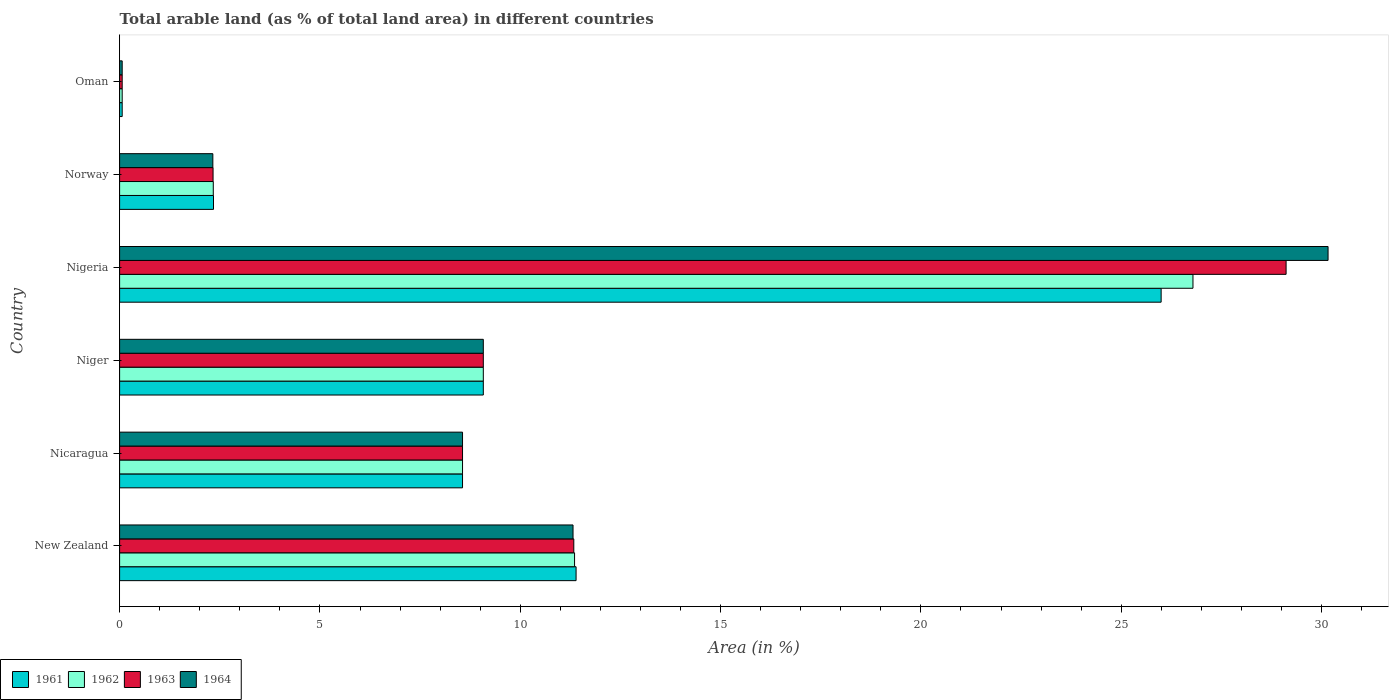How many different coloured bars are there?
Your answer should be very brief. 4. How many groups of bars are there?
Provide a short and direct response. 6. Are the number of bars on each tick of the Y-axis equal?
Your answer should be very brief. Yes. What is the label of the 1st group of bars from the top?
Make the answer very short. Oman. In how many cases, is the number of bars for a given country not equal to the number of legend labels?
Provide a succinct answer. 0. What is the percentage of arable land in 1964 in Niger?
Your answer should be very brief. 9.08. Across all countries, what is the maximum percentage of arable land in 1964?
Offer a very short reply. 30.16. Across all countries, what is the minimum percentage of arable land in 1961?
Your answer should be compact. 0.06. In which country was the percentage of arable land in 1961 maximum?
Provide a succinct answer. Nigeria. In which country was the percentage of arable land in 1961 minimum?
Provide a succinct answer. Oman. What is the total percentage of arable land in 1962 in the graph?
Your answer should be very brief. 58.19. What is the difference between the percentage of arable land in 1962 in New Zealand and that in Nicaragua?
Provide a short and direct response. 2.8. What is the difference between the percentage of arable land in 1962 in Nigeria and the percentage of arable land in 1961 in Oman?
Ensure brevity in your answer.  26.73. What is the average percentage of arable land in 1962 per country?
Your response must be concise. 9.7. What is the difference between the percentage of arable land in 1961 and percentage of arable land in 1964 in New Zealand?
Keep it short and to the point. 0.08. In how many countries, is the percentage of arable land in 1962 greater than 21 %?
Make the answer very short. 1. What is the ratio of the percentage of arable land in 1961 in Nicaragua to that in Oman?
Provide a succinct answer. 132.45. Is the percentage of arable land in 1962 in Nicaragua less than that in Nigeria?
Provide a succinct answer. Yes. What is the difference between the highest and the second highest percentage of arable land in 1963?
Your answer should be very brief. 17.78. What is the difference between the highest and the lowest percentage of arable land in 1961?
Offer a very short reply. 25.93. Is the sum of the percentage of arable land in 1961 in Nicaragua and Oman greater than the maximum percentage of arable land in 1963 across all countries?
Your answer should be very brief. No. What does the 2nd bar from the top in New Zealand represents?
Your response must be concise. 1963. What does the 4th bar from the bottom in Norway represents?
Offer a terse response. 1964. How many bars are there?
Provide a succinct answer. 24. Are all the bars in the graph horizontal?
Your answer should be compact. Yes. How are the legend labels stacked?
Offer a terse response. Horizontal. What is the title of the graph?
Ensure brevity in your answer.  Total arable land (as % of total land area) in different countries. What is the label or title of the X-axis?
Offer a terse response. Area (in %). What is the Area (in %) in 1961 in New Zealand?
Your response must be concise. 11.39. What is the Area (in %) in 1962 in New Zealand?
Keep it short and to the point. 11.36. What is the Area (in %) in 1963 in New Zealand?
Your response must be concise. 11.34. What is the Area (in %) in 1964 in New Zealand?
Offer a very short reply. 11.32. What is the Area (in %) of 1961 in Nicaragua?
Give a very brief answer. 8.56. What is the Area (in %) of 1962 in Nicaragua?
Offer a terse response. 8.56. What is the Area (in %) in 1963 in Nicaragua?
Ensure brevity in your answer.  8.56. What is the Area (in %) of 1964 in Nicaragua?
Ensure brevity in your answer.  8.56. What is the Area (in %) in 1961 in Niger?
Offer a very short reply. 9.08. What is the Area (in %) in 1962 in Niger?
Make the answer very short. 9.08. What is the Area (in %) in 1963 in Niger?
Your response must be concise. 9.08. What is the Area (in %) of 1964 in Niger?
Provide a short and direct response. 9.08. What is the Area (in %) of 1961 in Nigeria?
Ensure brevity in your answer.  26. What is the Area (in %) in 1962 in Nigeria?
Your answer should be very brief. 26.79. What is the Area (in %) of 1963 in Nigeria?
Give a very brief answer. 29.11. What is the Area (in %) in 1964 in Nigeria?
Your response must be concise. 30.16. What is the Area (in %) in 1961 in Norway?
Offer a very short reply. 2.34. What is the Area (in %) in 1962 in Norway?
Keep it short and to the point. 2.34. What is the Area (in %) in 1963 in Norway?
Your answer should be compact. 2.33. What is the Area (in %) in 1964 in Norway?
Keep it short and to the point. 2.33. What is the Area (in %) in 1961 in Oman?
Ensure brevity in your answer.  0.06. What is the Area (in %) of 1962 in Oman?
Keep it short and to the point. 0.06. What is the Area (in %) in 1963 in Oman?
Make the answer very short. 0.06. What is the Area (in %) in 1964 in Oman?
Your answer should be compact. 0.06. Across all countries, what is the maximum Area (in %) of 1961?
Ensure brevity in your answer.  26. Across all countries, what is the maximum Area (in %) of 1962?
Give a very brief answer. 26.79. Across all countries, what is the maximum Area (in %) of 1963?
Provide a short and direct response. 29.11. Across all countries, what is the maximum Area (in %) of 1964?
Provide a succinct answer. 30.16. Across all countries, what is the minimum Area (in %) in 1961?
Provide a short and direct response. 0.06. Across all countries, what is the minimum Area (in %) in 1962?
Give a very brief answer. 0.06. Across all countries, what is the minimum Area (in %) in 1963?
Keep it short and to the point. 0.06. Across all countries, what is the minimum Area (in %) in 1964?
Ensure brevity in your answer.  0.06. What is the total Area (in %) in 1961 in the graph?
Keep it short and to the point. 57.43. What is the total Area (in %) in 1962 in the graph?
Ensure brevity in your answer.  58.19. What is the total Area (in %) of 1963 in the graph?
Your response must be concise. 60.49. What is the total Area (in %) of 1964 in the graph?
Provide a succinct answer. 61.51. What is the difference between the Area (in %) of 1961 in New Zealand and that in Nicaragua?
Provide a succinct answer. 2.83. What is the difference between the Area (in %) of 1962 in New Zealand and that in Nicaragua?
Ensure brevity in your answer.  2.8. What is the difference between the Area (in %) of 1963 in New Zealand and that in Nicaragua?
Give a very brief answer. 2.78. What is the difference between the Area (in %) of 1964 in New Zealand and that in Nicaragua?
Keep it short and to the point. 2.76. What is the difference between the Area (in %) in 1961 in New Zealand and that in Niger?
Keep it short and to the point. 2.32. What is the difference between the Area (in %) of 1962 in New Zealand and that in Niger?
Make the answer very short. 2.28. What is the difference between the Area (in %) of 1963 in New Zealand and that in Niger?
Give a very brief answer. 2.26. What is the difference between the Area (in %) of 1964 in New Zealand and that in Niger?
Keep it short and to the point. 2.24. What is the difference between the Area (in %) in 1961 in New Zealand and that in Nigeria?
Your response must be concise. -14.6. What is the difference between the Area (in %) in 1962 in New Zealand and that in Nigeria?
Offer a very short reply. -15.44. What is the difference between the Area (in %) in 1963 in New Zealand and that in Nigeria?
Give a very brief answer. -17.78. What is the difference between the Area (in %) of 1964 in New Zealand and that in Nigeria?
Offer a very short reply. -18.84. What is the difference between the Area (in %) in 1961 in New Zealand and that in Norway?
Offer a very short reply. 9.05. What is the difference between the Area (in %) in 1962 in New Zealand and that in Norway?
Your answer should be compact. 9.02. What is the difference between the Area (in %) of 1963 in New Zealand and that in Norway?
Your answer should be compact. 9. What is the difference between the Area (in %) in 1964 in New Zealand and that in Norway?
Make the answer very short. 8.99. What is the difference between the Area (in %) of 1961 in New Zealand and that in Oman?
Your response must be concise. 11.33. What is the difference between the Area (in %) in 1962 in New Zealand and that in Oman?
Provide a succinct answer. 11.29. What is the difference between the Area (in %) of 1963 in New Zealand and that in Oman?
Your response must be concise. 11.27. What is the difference between the Area (in %) in 1964 in New Zealand and that in Oman?
Provide a succinct answer. 11.25. What is the difference between the Area (in %) in 1961 in Nicaragua and that in Niger?
Your answer should be compact. -0.52. What is the difference between the Area (in %) in 1962 in Nicaragua and that in Niger?
Provide a succinct answer. -0.52. What is the difference between the Area (in %) in 1963 in Nicaragua and that in Niger?
Provide a short and direct response. -0.52. What is the difference between the Area (in %) in 1964 in Nicaragua and that in Niger?
Keep it short and to the point. -0.52. What is the difference between the Area (in %) of 1961 in Nicaragua and that in Nigeria?
Offer a terse response. -17.44. What is the difference between the Area (in %) in 1962 in Nicaragua and that in Nigeria?
Provide a succinct answer. -18.23. What is the difference between the Area (in %) in 1963 in Nicaragua and that in Nigeria?
Provide a succinct answer. -20.56. What is the difference between the Area (in %) in 1964 in Nicaragua and that in Nigeria?
Provide a succinct answer. -21.6. What is the difference between the Area (in %) in 1961 in Nicaragua and that in Norway?
Provide a succinct answer. 6.22. What is the difference between the Area (in %) of 1962 in Nicaragua and that in Norway?
Your answer should be compact. 6.22. What is the difference between the Area (in %) in 1963 in Nicaragua and that in Norway?
Ensure brevity in your answer.  6.23. What is the difference between the Area (in %) in 1964 in Nicaragua and that in Norway?
Keep it short and to the point. 6.23. What is the difference between the Area (in %) in 1961 in Nicaragua and that in Oman?
Offer a terse response. 8.49. What is the difference between the Area (in %) in 1962 in Nicaragua and that in Oman?
Provide a short and direct response. 8.49. What is the difference between the Area (in %) in 1963 in Nicaragua and that in Oman?
Give a very brief answer. 8.49. What is the difference between the Area (in %) in 1964 in Nicaragua and that in Oman?
Keep it short and to the point. 8.49. What is the difference between the Area (in %) in 1961 in Niger and that in Nigeria?
Offer a terse response. -16.92. What is the difference between the Area (in %) of 1962 in Niger and that in Nigeria?
Give a very brief answer. -17.71. What is the difference between the Area (in %) in 1963 in Niger and that in Nigeria?
Ensure brevity in your answer.  -20.04. What is the difference between the Area (in %) in 1964 in Niger and that in Nigeria?
Make the answer very short. -21.08. What is the difference between the Area (in %) of 1961 in Niger and that in Norway?
Your answer should be very brief. 6.73. What is the difference between the Area (in %) in 1962 in Niger and that in Norway?
Keep it short and to the point. 6.74. What is the difference between the Area (in %) of 1963 in Niger and that in Norway?
Provide a succinct answer. 6.75. What is the difference between the Area (in %) in 1964 in Niger and that in Norway?
Your response must be concise. 6.75. What is the difference between the Area (in %) of 1961 in Niger and that in Oman?
Provide a short and direct response. 9.01. What is the difference between the Area (in %) of 1962 in Niger and that in Oman?
Your response must be concise. 9.01. What is the difference between the Area (in %) in 1963 in Niger and that in Oman?
Give a very brief answer. 9.01. What is the difference between the Area (in %) in 1964 in Niger and that in Oman?
Make the answer very short. 9.01. What is the difference between the Area (in %) in 1961 in Nigeria and that in Norway?
Give a very brief answer. 23.65. What is the difference between the Area (in %) of 1962 in Nigeria and that in Norway?
Your answer should be very brief. 24.45. What is the difference between the Area (in %) of 1963 in Nigeria and that in Norway?
Offer a terse response. 26.78. What is the difference between the Area (in %) of 1964 in Nigeria and that in Norway?
Your response must be concise. 27.84. What is the difference between the Area (in %) of 1961 in Nigeria and that in Oman?
Provide a short and direct response. 25.93. What is the difference between the Area (in %) of 1962 in Nigeria and that in Oman?
Provide a succinct answer. 26.73. What is the difference between the Area (in %) of 1963 in Nigeria and that in Oman?
Ensure brevity in your answer.  29.05. What is the difference between the Area (in %) of 1964 in Nigeria and that in Oman?
Provide a short and direct response. 30.1. What is the difference between the Area (in %) in 1961 in Norway and that in Oman?
Provide a succinct answer. 2.28. What is the difference between the Area (in %) of 1962 in Norway and that in Oman?
Give a very brief answer. 2.27. What is the difference between the Area (in %) of 1963 in Norway and that in Oman?
Ensure brevity in your answer.  2.27. What is the difference between the Area (in %) in 1964 in Norway and that in Oman?
Offer a very short reply. 2.26. What is the difference between the Area (in %) in 1961 in New Zealand and the Area (in %) in 1962 in Nicaragua?
Your answer should be very brief. 2.83. What is the difference between the Area (in %) in 1961 in New Zealand and the Area (in %) in 1963 in Nicaragua?
Your response must be concise. 2.83. What is the difference between the Area (in %) of 1961 in New Zealand and the Area (in %) of 1964 in Nicaragua?
Give a very brief answer. 2.83. What is the difference between the Area (in %) in 1962 in New Zealand and the Area (in %) in 1963 in Nicaragua?
Your answer should be very brief. 2.8. What is the difference between the Area (in %) in 1962 in New Zealand and the Area (in %) in 1964 in Nicaragua?
Offer a very short reply. 2.8. What is the difference between the Area (in %) of 1963 in New Zealand and the Area (in %) of 1964 in Nicaragua?
Offer a terse response. 2.78. What is the difference between the Area (in %) in 1961 in New Zealand and the Area (in %) in 1962 in Niger?
Offer a terse response. 2.32. What is the difference between the Area (in %) of 1961 in New Zealand and the Area (in %) of 1963 in Niger?
Provide a succinct answer. 2.32. What is the difference between the Area (in %) in 1961 in New Zealand and the Area (in %) in 1964 in Niger?
Give a very brief answer. 2.32. What is the difference between the Area (in %) of 1962 in New Zealand and the Area (in %) of 1963 in Niger?
Offer a very short reply. 2.28. What is the difference between the Area (in %) of 1962 in New Zealand and the Area (in %) of 1964 in Niger?
Make the answer very short. 2.28. What is the difference between the Area (in %) of 1963 in New Zealand and the Area (in %) of 1964 in Niger?
Your answer should be very brief. 2.26. What is the difference between the Area (in %) of 1961 in New Zealand and the Area (in %) of 1962 in Nigeria?
Your answer should be very brief. -15.4. What is the difference between the Area (in %) of 1961 in New Zealand and the Area (in %) of 1963 in Nigeria?
Your answer should be very brief. -17.72. What is the difference between the Area (in %) of 1961 in New Zealand and the Area (in %) of 1964 in Nigeria?
Ensure brevity in your answer.  -18.77. What is the difference between the Area (in %) of 1962 in New Zealand and the Area (in %) of 1963 in Nigeria?
Ensure brevity in your answer.  -17.76. What is the difference between the Area (in %) in 1962 in New Zealand and the Area (in %) in 1964 in Nigeria?
Provide a succinct answer. -18.81. What is the difference between the Area (in %) of 1963 in New Zealand and the Area (in %) of 1964 in Nigeria?
Your response must be concise. -18.83. What is the difference between the Area (in %) in 1961 in New Zealand and the Area (in %) in 1962 in Norway?
Your response must be concise. 9.06. What is the difference between the Area (in %) of 1961 in New Zealand and the Area (in %) of 1963 in Norway?
Keep it short and to the point. 9.06. What is the difference between the Area (in %) of 1961 in New Zealand and the Area (in %) of 1964 in Norway?
Provide a succinct answer. 9.07. What is the difference between the Area (in %) in 1962 in New Zealand and the Area (in %) in 1963 in Norway?
Offer a terse response. 9.02. What is the difference between the Area (in %) in 1962 in New Zealand and the Area (in %) in 1964 in Norway?
Make the answer very short. 9.03. What is the difference between the Area (in %) of 1963 in New Zealand and the Area (in %) of 1964 in Norway?
Provide a succinct answer. 9.01. What is the difference between the Area (in %) of 1961 in New Zealand and the Area (in %) of 1962 in Oman?
Provide a short and direct response. 11.33. What is the difference between the Area (in %) of 1961 in New Zealand and the Area (in %) of 1963 in Oman?
Give a very brief answer. 11.33. What is the difference between the Area (in %) of 1961 in New Zealand and the Area (in %) of 1964 in Oman?
Make the answer very short. 11.33. What is the difference between the Area (in %) of 1962 in New Zealand and the Area (in %) of 1963 in Oman?
Provide a short and direct response. 11.29. What is the difference between the Area (in %) in 1962 in New Zealand and the Area (in %) in 1964 in Oman?
Your answer should be compact. 11.29. What is the difference between the Area (in %) of 1963 in New Zealand and the Area (in %) of 1964 in Oman?
Make the answer very short. 11.27. What is the difference between the Area (in %) of 1961 in Nicaragua and the Area (in %) of 1962 in Niger?
Offer a very short reply. -0.52. What is the difference between the Area (in %) in 1961 in Nicaragua and the Area (in %) in 1963 in Niger?
Your answer should be compact. -0.52. What is the difference between the Area (in %) of 1961 in Nicaragua and the Area (in %) of 1964 in Niger?
Provide a succinct answer. -0.52. What is the difference between the Area (in %) of 1962 in Nicaragua and the Area (in %) of 1963 in Niger?
Provide a short and direct response. -0.52. What is the difference between the Area (in %) in 1962 in Nicaragua and the Area (in %) in 1964 in Niger?
Give a very brief answer. -0.52. What is the difference between the Area (in %) of 1963 in Nicaragua and the Area (in %) of 1964 in Niger?
Offer a very short reply. -0.52. What is the difference between the Area (in %) in 1961 in Nicaragua and the Area (in %) in 1962 in Nigeria?
Make the answer very short. -18.23. What is the difference between the Area (in %) of 1961 in Nicaragua and the Area (in %) of 1963 in Nigeria?
Make the answer very short. -20.56. What is the difference between the Area (in %) of 1961 in Nicaragua and the Area (in %) of 1964 in Nigeria?
Ensure brevity in your answer.  -21.6. What is the difference between the Area (in %) of 1962 in Nicaragua and the Area (in %) of 1963 in Nigeria?
Ensure brevity in your answer.  -20.56. What is the difference between the Area (in %) of 1962 in Nicaragua and the Area (in %) of 1964 in Nigeria?
Provide a short and direct response. -21.6. What is the difference between the Area (in %) of 1963 in Nicaragua and the Area (in %) of 1964 in Nigeria?
Your answer should be compact. -21.6. What is the difference between the Area (in %) in 1961 in Nicaragua and the Area (in %) in 1962 in Norway?
Provide a succinct answer. 6.22. What is the difference between the Area (in %) in 1961 in Nicaragua and the Area (in %) in 1963 in Norway?
Make the answer very short. 6.23. What is the difference between the Area (in %) in 1961 in Nicaragua and the Area (in %) in 1964 in Norway?
Your answer should be very brief. 6.23. What is the difference between the Area (in %) of 1962 in Nicaragua and the Area (in %) of 1963 in Norway?
Provide a succinct answer. 6.23. What is the difference between the Area (in %) of 1962 in Nicaragua and the Area (in %) of 1964 in Norway?
Ensure brevity in your answer.  6.23. What is the difference between the Area (in %) in 1963 in Nicaragua and the Area (in %) in 1964 in Norway?
Your answer should be compact. 6.23. What is the difference between the Area (in %) of 1961 in Nicaragua and the Area (in %) of 1962 in Oman?
Your answer should be compact. 8.49. What is the difference between the Area (in %) of 1961 in Nicaragua and the Area (in %) of 1963 in Oman?
Offer a terse response. 8.49. What is the difference between the Area (in %) in 1961 in Nicaragua and the Area (in %) in 1964 in Oman?
Your response must be concise. 8.49. What is the difference between the Area (in %) in 1962 in Nicaragua and the Area (in %) in 1963 in Oman?
Make the answer very short. 8.49. What is the difference between the Area (in %) in 1962 in Nicaragua and the Area (in %) in 1964 in Oman?
Offer a very short reply. 8.49. What is the difference between the Area (in %) of 1963 in Nicaragua and the Area (in %) of 1964 in Oman?
Give a very brief answer. 8.49. What is the difference between the Area (in %) of 1961 in Niger and the Area (in %) of 1962 in Nigeria?
Keep it short and to the point. -17.71. What is the difference between the Area (in %) in 1961 in Niger and the Area (in %) in 1963 in Nigeria?
Your response must be concise. -20.04. What is the difference between the Area (in %) in 1961 in Niger and the Area (in %) in 1964 in Nigeria?
Your response must be concise. -21.08. What is the difference between the Area (in %) in 1962 in Niger and the Area (in %) in 1963 in Nigeria?
Offer a very short reply. -20.04. What is the difference between the Area (in %) in 1962 in Niger and the Area (in %) in 1964 in Nigeria?
Offer a very short reply. -21.08. What is the difference between the Area (in %) in 1963 in Niger and the Area (in %) in 1964 in Nigeria?
Your answer should be compact. -21.08. What is the difference between the Area (in %) of 1961 in Niger and the Area (in %) of 1962 in Norway?
Provide a succinct answer. 6.74. What is the difference between the Area (in %) of 1961 in Niger and the Area (in %) of 1963 in Norway?
Offer a very short reply. 6.75. What is the difference between the Area (in %) of 1961 in Niger and the Area (in %) of 1964 in Norway?
Your answer should be compact. 6.75. What is the difference between the Area (in %) in 1962 in Niger and the Area (in %) in 1963 in Norway?
Give a very brief answer. 6.75. What is the difference between the Area (in %) in 1962 in Niger and the Area (in %) in 1964 in Norway?
Your response must be concise. 6.75. What is the difference between the Area (in %) in 1963 in Niger and the Area (in %) in 1964 in Norway?
Offer a very short reply. 6.75. What is the difference between the Area (in %) of 1961 in Niger and the Area (in %) of 1962 in Oman?
Ensure brevity in your answer.  9.01. What is the difference between the Area (in %) of 1961 in Niger and the Area (in %) of 1963 in Oman?
Your answer should be very brief. 9.01. What is the difference between the Area (in %) of 1961 in Niger and the Area (in %) of 1964 in Oman?
Your response must be concise. 9.01. What is the difference between the Area (in %) of 1962 in Niger and the Area (in %) of 1963 in Oman?
Keep it short and to the point. 9.01. What is the difference between the Area (in %) of 1962 in Niger and the Area (in %) of 1964 in Oman?
Give a very brief answer. 9.01. What is the difference between the Area (in %) in 1963 in Niger and the Area (in %) in 1964 in Oman?
Offer a very short reply. 9.01. What is the difference between the Area (in %) in 1961 in Nigeria and the Area (in %) in 1962 in Norway?
Offer a very short reply. 23.66. What is the difference between the Area (in %) in 1961 in Nigeria and the Area (in %) in 1963 in Norway?
Your response must be concise. 23.66. What is the difference between the Area (in %) of 1961 in Nigeria and the Area (in %) of 1964 in Norway?
Your answer should be compact. 23.67. What is the difference between the Area (in %) of 1962 in Nigeria and the Area (in %) of 1963 in Norway?
Your response must be concise. 24.46. What is the difference between the Area (in %) of 1962 in Nigeria and the Area (in %) of 1964 in Norway?
Offer a very short reply. 24.46. What is the difference between the Area (in %) of 1963 in Nigeria and the Area (in %) of 1964 in Norway?
Give a very brief answer. 26.79. What is the difference between the Area (in %) in 1961 in Nigeria and the Area (in %) in 1962 in Oman?
Your answer should be compact. 25.93. What is the difference between the Area (in %) in 1961 in Nigeria and the Area (in %) in 1963 in Oman?
Provide a short and direct response. 25.93. What is the difference between the Area (in %) in 1961 in Nigeria and the Area (in %) in 1964 in Oman?
Provide a succinct answer. 25.93. What is the difference between the Area (in %) in 1962 in Nigeria and the Area (in %) in 1963 in Oman?
Provide a short and direct response. 26.73. What is the difference between the Area (in %) in 1962 in Nigeria and the Area (in %) in 1964 in Oman?
Your answer should be compact. 26.73. What is the difference between the Area (in %) in 1963 in Nigeria and the Area (in %) in 1964 in Oman?
Offer a terse response. 29.05. What is the difference between the Area (in %) in 1961 in Norway and the Area (in %) in 1962 in Oman?
Ensure brevity in your answer.  2.28. What is the difference between the Area (in %) in 1961 in Norway and the Area (in %) in 1963 in Oman?
Ensure brevity in your answer.  2.28. What is the difference between the Area (in %) in 1961 in Norway and the Area (in %) in 1964 in Oman?
Keep it short and to the point. 2.28. What is the difference between the Area (in %) of 1962 in Norway and the Area (in %) of 1963 in Oman?
Make the answer very short. 2.27. What is the difference between the Area (in %) in 1962 in Norway and the Area (in %) in 1964 in Oman?
Your answer should be very brief. 2.27. What is the difference between the Area (in %) in 1963 in Norway and the Area (in %) in 1964 in Oman?
Your answer should be compact. 2.27. What is the average Area (in %) of 1961 per country?
Provide a short and direct response. 9.57. What is the average Area (in %) of 1962 per country?
Provide a short and direct response. 9.7. What is the average Area (in %) of 1963 per country?
Your answer should be compact. 10.08. What is the average Area (in %) in 1964 per country?
Provide a succinct answer. 10.25. What is the difference between the Area (in %) of 1961 and Area (in %) of 1962 in New Zealand?
Your answer should be very brief. 0.04. What is the difference between the Area (in %) in 1961 and Area (in %) in 1963 in New Zealand?
Provide a short and direct response. 0.06. What is the difference between the Area (in %) in 1961 and Area (in %) in 1964 in New Zealand?
Provide a succinct answer. 0.08. What is the difference between the Area (in %) of 1962 and Area (in %) of 1963 in New Zealand?
Provide a succinct answer. 0.02. What is the difference between the Area (in %) of 1962 and Area (in %) of 1964 in New Zealand?
Make the answer very short. 0.04. What is the difference between the Area (in %) in 1963 and Area (in %) in 1964 in New Zealand?
Keep it short and to the point. 0.02. What is the difference between the Area (in %) in 1961 and Area (in %) in 1962 in Nicaragua?
Make the answer very short. 0. What is the difference between the Area (in %) of 1961 and Area (in %) of 1963 in Nicaragua?
Offer a terse response. 0. What is the difference between the Area (in %) of 1962 and Area (in %) of 1964 in Nicaragua?
Ensure brevity in your answer.  0. What is the difference between the Area (in %) of 1963 and Area (in %) of 1964 in Nicaragua?
Provide a succinct answer. 0. What is the difference between the Area (in %) in 1961 and Area (in %) in 1962 in Niger?
Your answer should be compact. 0. What is the difference between the Area (in %) of 1961 and Area (in %) of 1963 in Niger?
Keep it short and to the point. 0. What is the difference between the Area (in %) in 1962 and Area (in %) in 1963 in Niger?
Offer a very short reply. 0. What is the difference between the Area (in %) of 1963 and Area (in %) of 1964 in Niger?
Make the answer very short. 0. What is the difference between the Area (in %) in 1961 and Area (in %) in 1962 in Nigeria?
Provide a succinct answer. -0.79. What is the difference between the Area (in %) of 1961 and Area (in %) of 1963 in Nigeria?
Your answer should be very brief. -3.12. What is the difference between the Area (in %) in 1961 and Area (in %) in 1964 in Nigeria?
Give a very brief answer. -4.17. What is the difference between the Area (in %) of 1962 and Area (in %) of 1963 in Nigeria?
Provide a short and direct response. -2.32. What is the difference between the Area (in %) in 1962 and Area (in %) in 1964 in Nigeria?
Make the answer very short. -3.37. What is the difference between the Area (in %) in 1963 and Area (in %) in 1964 in Nigeria?
Your response must be concise. -1.05. What is the difference between the Area (in %) in 1961 and Area (in %) in 1962 in Norway?
Keep it short and to the point. 0.01. What is the difference between the Area (in %) of 1961 and Area (in %) of 1963 in Norway?
Offer a terse response. 0.01. What is the difference between the Area (in %) of 1961 and Area (in %) of 1964 in Norway?
Offer a terse response. 0.02. What is the difference between the Area (in %) in 1962 and Area (in %) in 1963 in Norway?
Make the answer very short. 0.01. What is the difference between the Area (in %) of 1962 and Area (in %) of 1964 in Norway?
Your answer should be very brief. 0.01. What is the difference between the Area (in %) in 1963 and Area (in %) in 1964 in Norway?
Offer a terse response. 0.01. What is the difference between the Area (in %) of 1961 and Area (in %) of 1963 in Oman?
Your answer should be compact. 0. What is the difference between the Area (in %) in 1962 and Area (in %) in 1964 in Oman?
Give a very brief answer. 0. What is the difference between the Area (in %) in 1963 and Area (in %) in 1964 in Oman?
Keep it short and to the point. 0. What is the ratio of the Area (in %) of 1961 in New Zealand to that in Nicaragua?
Keep it short and to the point. 1.33. What is the ratio of the Area (in %) of 1962 in New Zealand to that in Nicaragua?
Your answer should be compact. 1.33. What is the ratio of the Area (in %) in 1963 in New Zealand to that in Nicaragua?
Provide a short and direct response. 1.32. What is the ratio of the Area (in %) in 1964 in New Zealand to that in Nicaragua?
Give a very brief answer. 1.32. What is the ratio of the Area (in %) of 1961 in New Zealand to that in Niger?
Ensure brevity in your answer.  1.26. What is the ratio of the Area (in %) in 1962 in New Zealand to that in Niger?
Provide a succinct answer. 1.25. What is the ratio of the Area (in %) of 1963 in New Zealand to that in Niger?
Your response must be concise. 1.25. What is the ratio of the Area (in %) in 1964 in New Zealand to that in Niger?
Offer a terse response. 1.25. What is the ratio of the Area (in %) in 1961 in New Zealand to that in Nigeria?
Provide a short and direct response. 0.44. What is the ratio of the Area (in %) of 1962 in New Zealand to that in Nigeria?
Offer a terse response. 0.42. What is the ratio of the Area (in %) in 1963 in New Zealand to that in Nigeria?
Offer a terse response. 0.39. What is the ratio of the Area (in %) of 1964 in New Zealand to that in Nigeria?
Make the answer very short. 0.38. What is the ratio of the Area (in %) in 1961 in New Zealand to that in Norway?
Give a very brief answer. 4.86. What is the ratio of the Area (in %) in 1962 in New Zealand to that in Norway?
Your answer should be very brief. 4.86. What is the ratio of the Area (in %) in 1963 in New Zealand to that in Norway?
Your answer should be compact. 4.86. What is the ratio of the Area (in %) in 1964 in New Zealand to that in Norway?
Offer a very short reply. 4.86. What is the ratio of the Area (in %) in 1961 in New Zealand to that in Oman?
Keep it short and to the point. 176.31. What is the ratio of the Area (in %) in 1962 in New Zealand to that in Oman?
Make the answer very short. 175.73. What is the ratio of the Area (in %) in 1963 in New Zealand to that in Oman?
Keep it short and to the point. 175.43. What is the ratio of the Area (in %) of 1964 in New Zealand to that in Oman?
Offer a terse response. 175.14. What is the ratio of the Area (in %) in 1961 in Nicaragua to that in Niger?
Offer a terse response. 0.94. What is the ratio of the Area (in %) in 1962 in Nicaragua to that in Niger?
Offer a very short reply. 0.94. What is the ratio of the Area (in %) of 1963 in Nicaragua to that in Niger?
Your answer should be very brief. 0.94. What is the ratio of the Area (in %) of 1964 in Nicaragua to that in Niger?
Make the answer very short. 0.94. What is the ratio of the Area (in %) of 1961 in Nicaragua to that in Nigeria?
Your answer should be compact. 0.33. What is the ratio of the Area (in %) in 1962 in Nicaragua to that in Nigeria?
Offer a terse response. 0.32. What is the ratio of the Area (in %) of 1963 in Nicaragua to that in Nigeria?
Make the answer very short. 0.29. What is the ratio of the Area (in %) of 1964 in Nicaragua to that in Nigeria?
Offer a terse response. 0.28. What is the ratio of the Area (in %) in 1961 in Nicaragua to that in Norway?
Provide a succinct answer. 3.65. What is the ratio of the Area (in %) of 1962 in Nicaragua to that in Norway?
Provide a succinct answer. 3.66. What is the ratio of the Area (in %) of 1963 in Nicaragua to that in Norway?
Your answer should be very brief. 3.67. What is the ratio of the Area (in %) of 1964 in Nicaragua to that in Norway?
Your response must be concise. 3.68. What is the ratio of the Area (in %) in 1961 in Nicaragua to that in Oman?
Keep it short and to the point. 132.45. What is the ratio of the Area (in %) in 1962 in Nicaragua to that in Oman?
Give a very brief answer. 132.45. What is the ratio of the Area (in %) of 1963 in Nicaragua to that in Oman?
Ensure brevity in your answer.  132.45. What is the ratio of the Area (in %) in 1964 in Nicaragua to that in Oman?
Give a very brief answer. 132.45. What is the ratio of the Area (in %) in 1961 in Niger to that in Nigeria?
Ensure brevity in your answer.  0.35. What is the ratio of the Area (in %) of 1962 in Niger to that in Nigeria?
Offer a terse response. 0.34. What is the ratio of the Area (in %) in 1963 in Niger to that in Nigeria?
Your answer should be very brief. 0.31. What is the ratio of the Area (in %) in 1964 in Niger to that in Nigeria?
Your answer should be compact. 0.3. What is the ratio of the Area (in %) in 1961 in Niger to that in Norway?
Provide a succinct answer. 3.87. What is the ratio of the Area (in %) in 1962 in Niger to that in Norway?
Your answer should be very brief. 3.88. What is the ratio of the Area (in %) in 1963 in Niger to that in Norway?
Your answer should be very brief. 3.89. What is the ratio of the Area (in %) in 1964 in Niger to that in Norway?
Your response must be concise. 3.9. What is the ratio of the Area (in %) of 1961 in Niger to that in Oman?
Make the answer very short. 140.48. What is the ratio of the Area (in %) of 1962 in Niger to that in Oman?
Ensure brevity in your answer.  140.48. What is the ratio of the Area (in %) of 1963 in Niger to that in Oman?
Ensure brevity in your answer.  140.48. What is the ratio of the Area (in %) of 1964 in Niger to that in Oman?
Your answer should be very brief. 140.48. What is the ratio of the Area (in %) in 1961 in Nigeria to that in Norway?
Your answer should be compact. 11.09. What is the ratio of the Area (in %) of 1962 in Nigeria to that in Norway?
Provide a succinct answer. 11.46. What is the ratio of the Area (in %) of 1963 in Nigeria to that in Norway?
Offer a very short reply. 12.48. What is the ratio of the Area (in %) in 1964 in Nigeria to that in Norway?
Provide a short and direct response. 12.96. What is the ratio of the Area (in %) of 1961 in Nigeria to that in Oman?
Keep it short and to the point. 402.29. What is the ratio of the Area (in %) in 1962 in Nigeria to that in Oman?
Your answer should be compact. 414.58. What is the ratio of the Area (in %) in 1963 in Nigeria to that in Oman?
Give a very brief answer. 450.55. What is the ratio of the Area (in %) in 1964 in Nigeria to that in Oman?
Offer a terse response. 466.76. What is the ratio of the Area (in %) in 1961 in Norway to that in Oman?
Ensure brevity in your answer.  36.27. What is the ratio of the Area (in %) in 1962 in Norway to that in Oman?
Provide a short and direct response. 36.18. What is the ratio of the Area (in %) of 1963 in Norway to that in Oman?
Your answer should be very brief. 36.1. What is the ratio of the Area (in %) in 1964 in Norway to that in Oman?
Offer a very short reply. 36.01. What is the difference between the highest and the second highest Area (in %) of 1961?
Ensure brevity in your answer.  14.6. What is the difference between the highest and the second highest Area (in %) of 1962?
Provide a short and direct response. 15.44. What is the difference between the highest and the second highest Area (in %) in 1963?
Offer a terse response. 17.78. What is the difference between the highest and the second highest Area (in %) in 1964?
Your answer should be very brief. 18.84. What is the difference between the highest and the lowest Area (in %) of 1961?
Offer a very short reply. 25.93. What is the difference between the highest and the lowest Area (in %) in 1962?
Your response must be concise. 26.73. What is the difference between the highest and the lowest Area (in %) in 1963?
Your answer should be compact. 29.05. What is the difference between the highest and the lowest Area (in %) of 1964?
Ensure brevity in your answer.  30.1. 